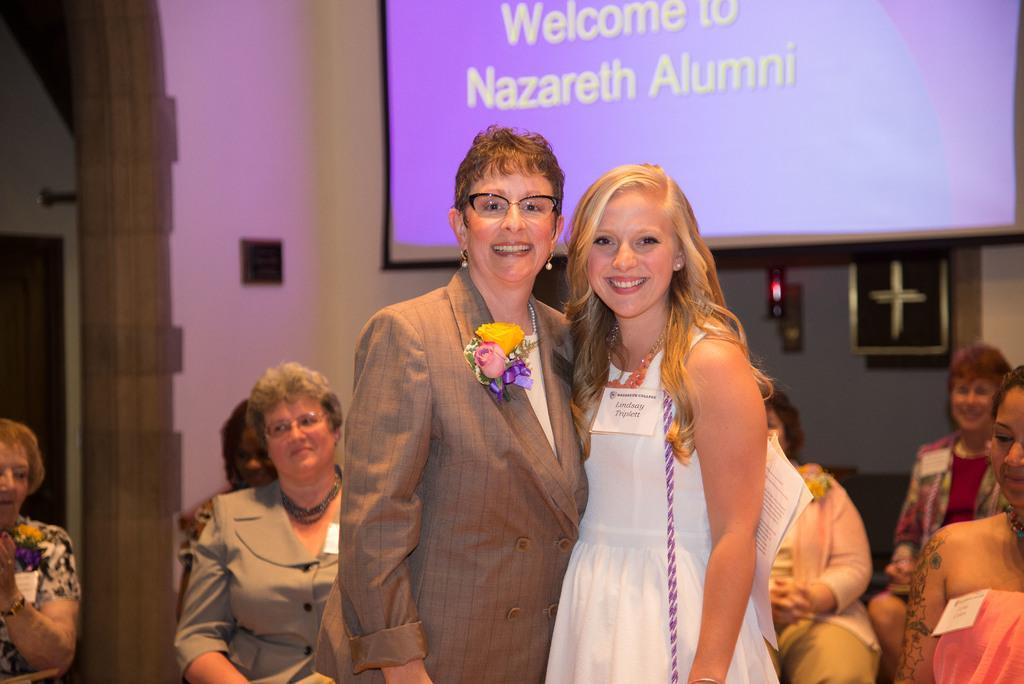In one or two sentences, can you explain what this image depicts? In this picture I can see two persons standing and smiling, there are group of people sitting, there are walls and there is a projector screen. 